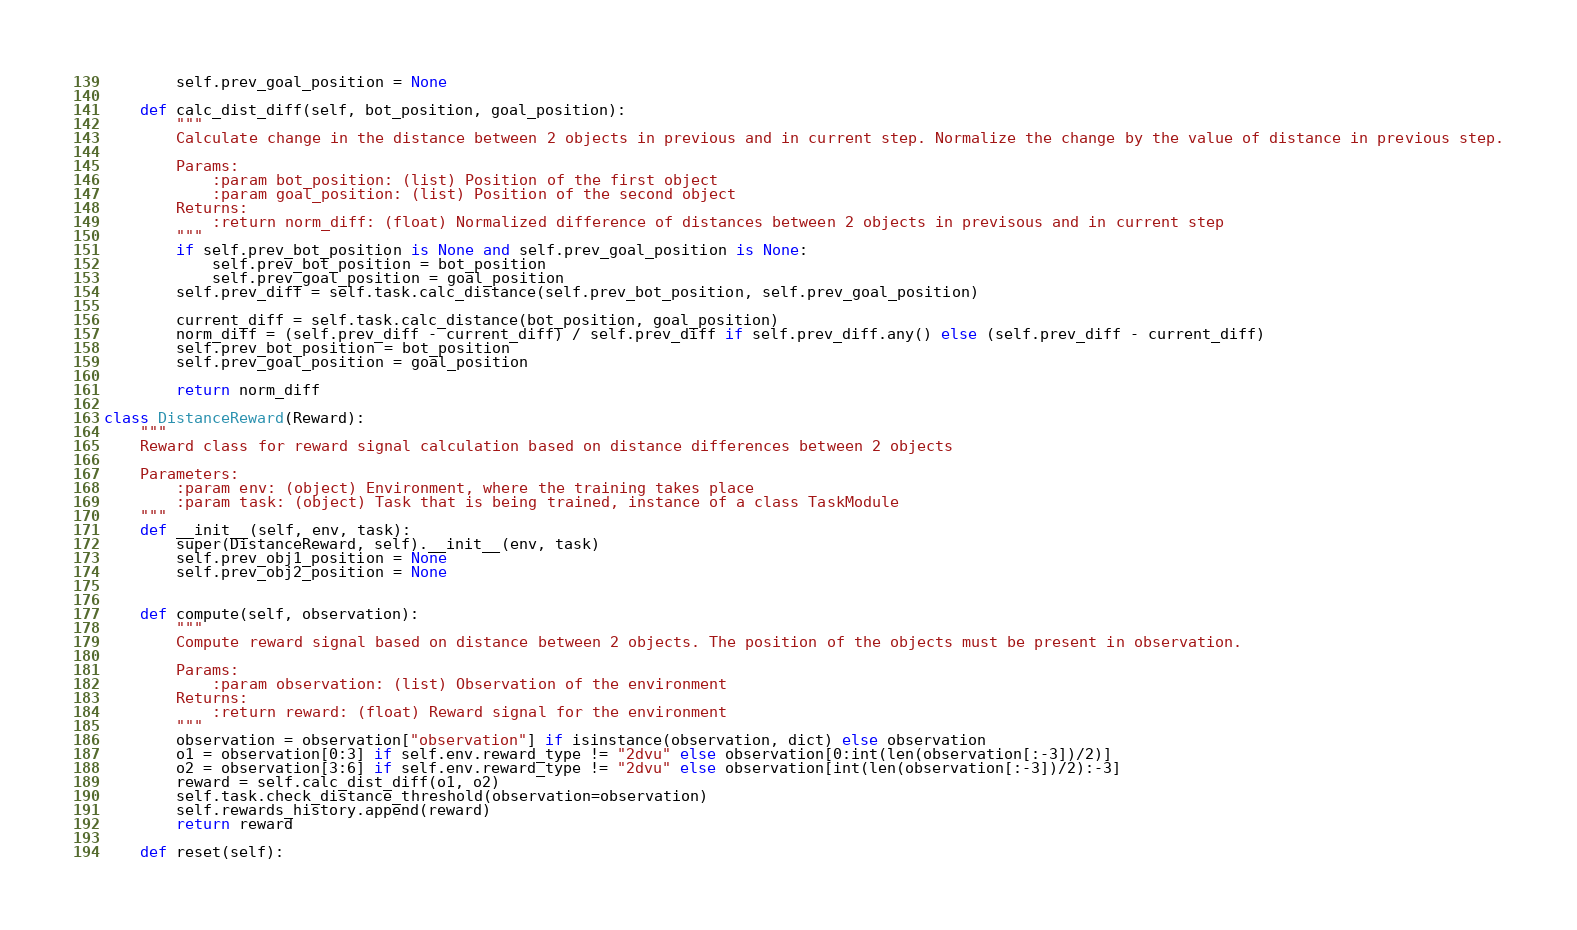<code> <loc_0><loc_0><loc_500><loc_500><_Python_>        self.prev_goal_position = None

    def calc_dist_diff(self, bot_position, goal_position):
        """
        Calculate change in the distance between 2 objects in previous and in current step. Normalize the change by the value of distance in previous step.

        Params:
            :param bot_position: (list) Position of the first object
            :param goal_position: (list) Position of the second object
        Returns:
            :return norm_diff: (float) Normalized difference of distances between 2 objects in previsous and in current step
        """
        if self.prev_bot_position is None and self.prev_goal_position is None:
            self.prev_bot_position = bot_position
            self.prev_goal_position = goal_position
        self.prev_diff = self.task.calc_distance(self.prev_bot_position, self.prev_goal_position)

        current_diff = self.task.calc_distance(bot_position, goal_position)
        norm_diff = (self.prev_diff - current_diff) / self.prev_diff if self.prev_diff.any() else (self.prev_diff - current_diff)
        self.prev_bot_position = bot_position
        self.prev_goal_position = goal_position

        return norm_diff

class DistanceReward(Reward):
    """
    Reward class for reward signal calculation based on distance differences between 2 objects

    Parameters:
        :param env: (object) Environment, where the training takes place
        :param task: (object) Task that is being trained, instance of a class TaskModule
    """
    def __init__(self, env, task):
        super(DistanceReward, self).__init__(env, task)
        self.prev_obj1_position = None
        self.prev_obj2_position = None


    def compute(self, observation):
        """
        Compute reward signal based on distance between 2 objects. The position of the objects must be present in observation.

        Params:
            :param observation: (list) Observation of the environment
        Returns:
            :return reward: (float) Reward signal for the environment
        """
        observation = observation["observation"] if isinstance(observation, dict) else observation
        o1 = observation[0:3] if self.env.reward_type != "2dvu" else observation[0:int(len(observation[:-3])/2)]
        o2 = observation[3:6] if self.env.reward_type != "2dvu" else observation[int(len(observation[:-3])/2):-3]
        reward = self.calc_dist_diff(o1, o2)
        self.task.check_distance_threshold(observation=observation)
        self.rewards_history.append(reward)
        return reward

    def reset(self):</code> 